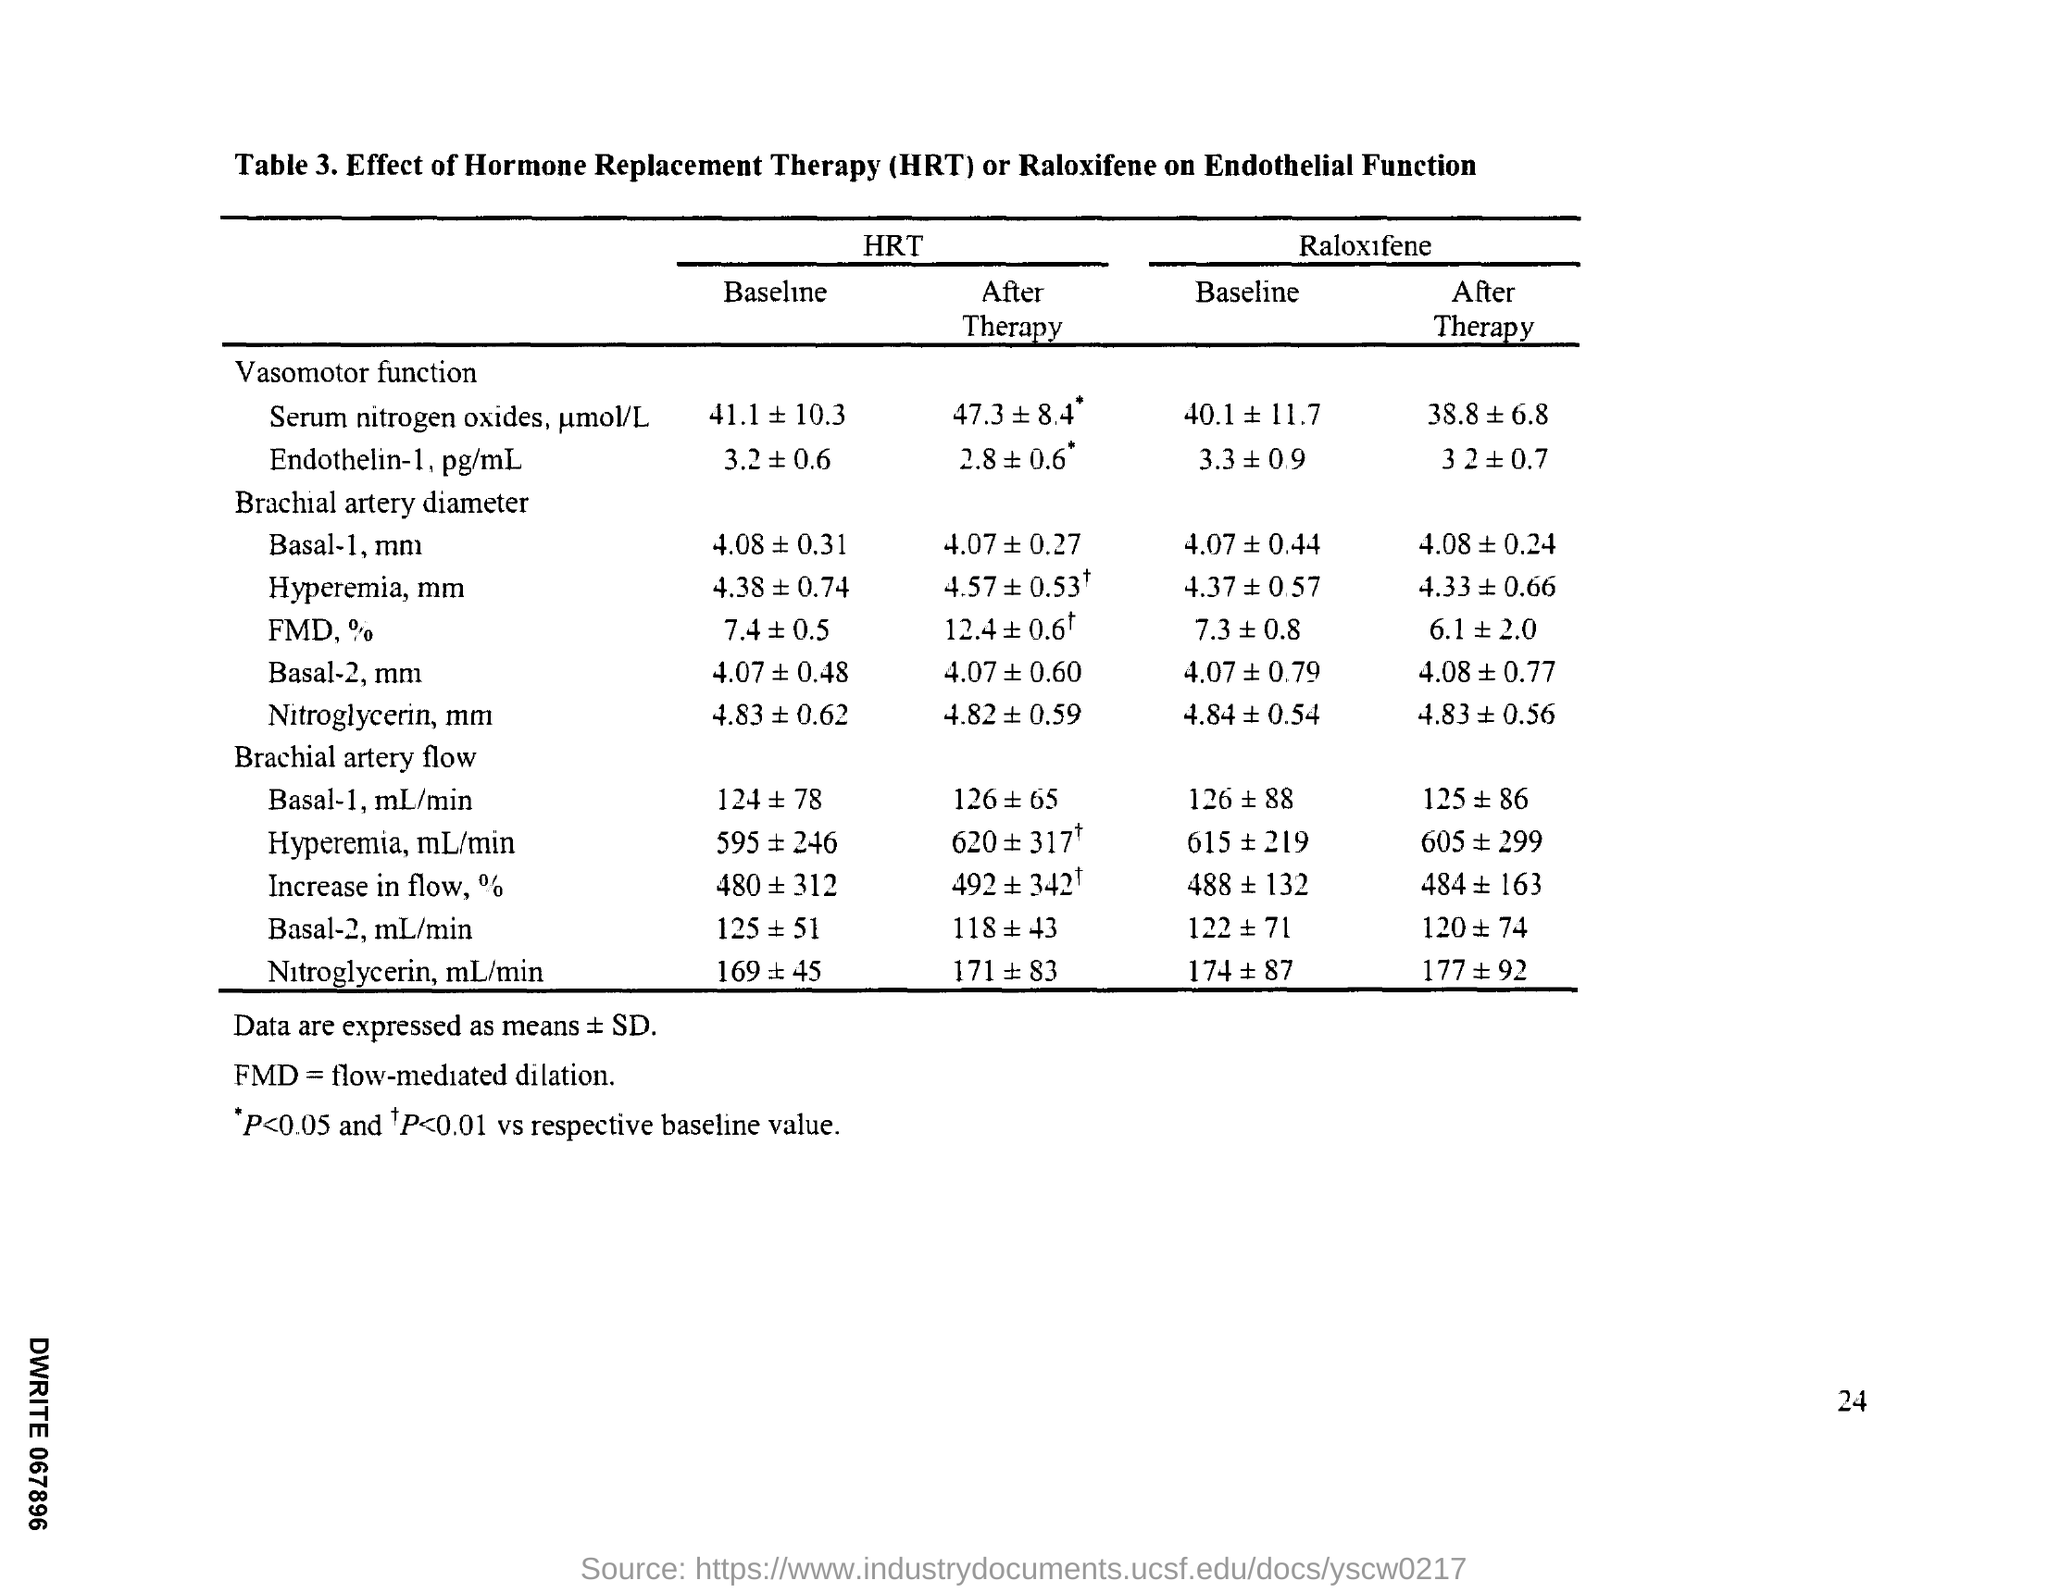What does HRT stand for?
Offer a very short reply. Hormone Replacement Therapy. 